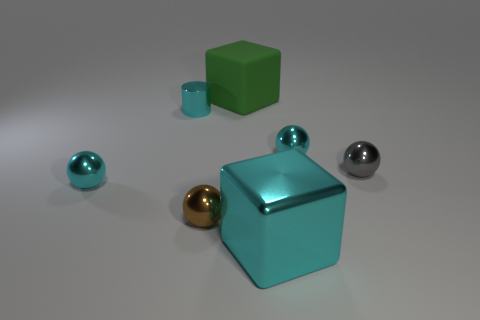Add 1 big red metallic blocks. How many objects exist? 8 Subtract all blocks. How many objects are left? 5 Subtract all metallic balls. Subtract all tiny cyan spheres. How many objects are left? 1 Add 1 small brown things. How many small brown things are left? 2 Add 2 tiny brown metal spheres. How many tiny brown metal spheres exist? 3 Subtract 1 gray spheres. How many objects are left? 6 